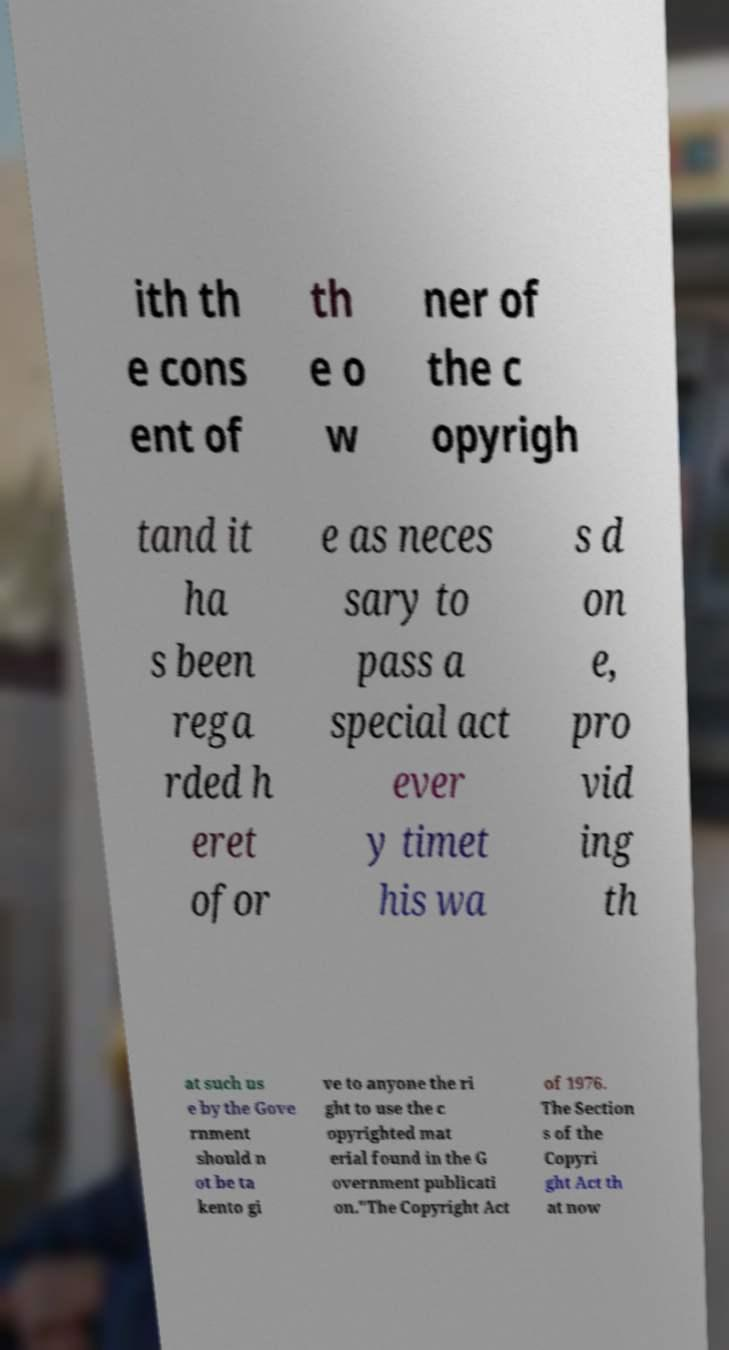There's text embedded in this image that I need extracted. Can you transcribe it verbatim? ith th e cons ent of th e o w ner of the c opyrigh tand it ha s been rega rded h eret ofor e as neces sary to pass a special act ever y timet his wa s d on e, pro vid ing th at such us e by the Gove rnment should n ot be ta kento gi ve to anyone the ri ght to use the c opyrighted mat erial found in the G overnment publicati on."The Copyright Act of 1976. The Section s of the Copyri ght Act th at now 